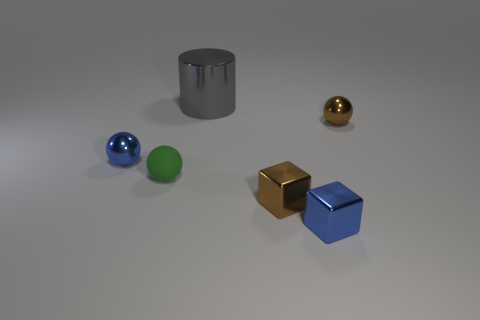What number of other things are the same material as the small blue block?
Provide a succinct answer. 4. Do the big gray shiny object and the blue shiny thing that is right of the cylinder have the same shape?
Your response must be concise. No. Is there any other thing that is the same size as the blue metallic cube?
Keep it short and to the point. Yes. What size is the brown shiny object that is the same shape as the green object?
Give a very brief answer. Small. Are there more big blue shiny blocks than large metal cylinders?
Offer a terse response. No. Is the shape of the matte thing the same as the large gray object?
Your answer should be compact. No. There is a tiny block to the left of the tiny blue shiny thing on the right side of the big gray shiny object; what is its material?
Make the answer very short. Metal. Do the blue sphere and the blue metal block have the same size?
Offer a terse response. Yes. There is a brown thing that is to the left of the brown metal ball; is there a big cylinder on the left side of it?
Offer a very short reply. Yes. What is the shape of the small brown metallic thing on the left side of the brown sphere?
Provide a short and direct response. Cube. 